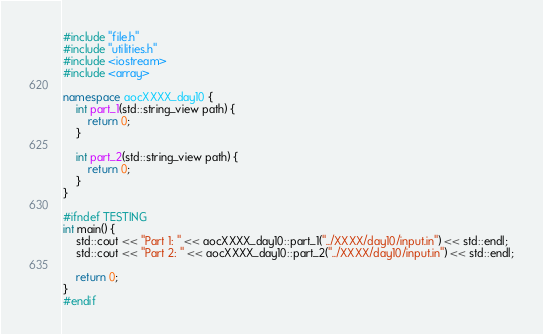<code> <loc_0><loc_0><loc_500><loc_500><_C++_>#include "file.h"
#include "utilities.h"
#include <iostream>
#include <array>

namespace aocXXXX_day10 {
    int part_1(std::string_view path) {
        return 0;
    }

    int part_2(std::string_view path) {
        return 0;
    }
}

#ifndef TESTING
int main() {
    std::cout << "Part 1: " << aocXXXX_day10::part_1("../XXXX/day10/input.in") << std::endl;
    std::cout << "Part 2: " << aocXXXX_day10::part_2("../XXXX/day10/input.in") << std::endl;

    return 0;
}
#endif
</code> 